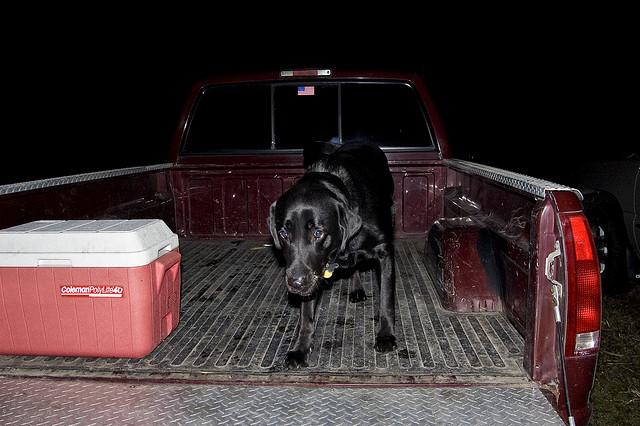Is this outside?
Quick response, please. Yes. What kind of animal is sitting on the pick up truck?
Answer briefly. Dog. Is it daytime?
Short answer required. No. What is displayed on the truck's back window?
Answer briefly. American flag. Are the dogs going for a drive?
Quick response, please. Yes. 